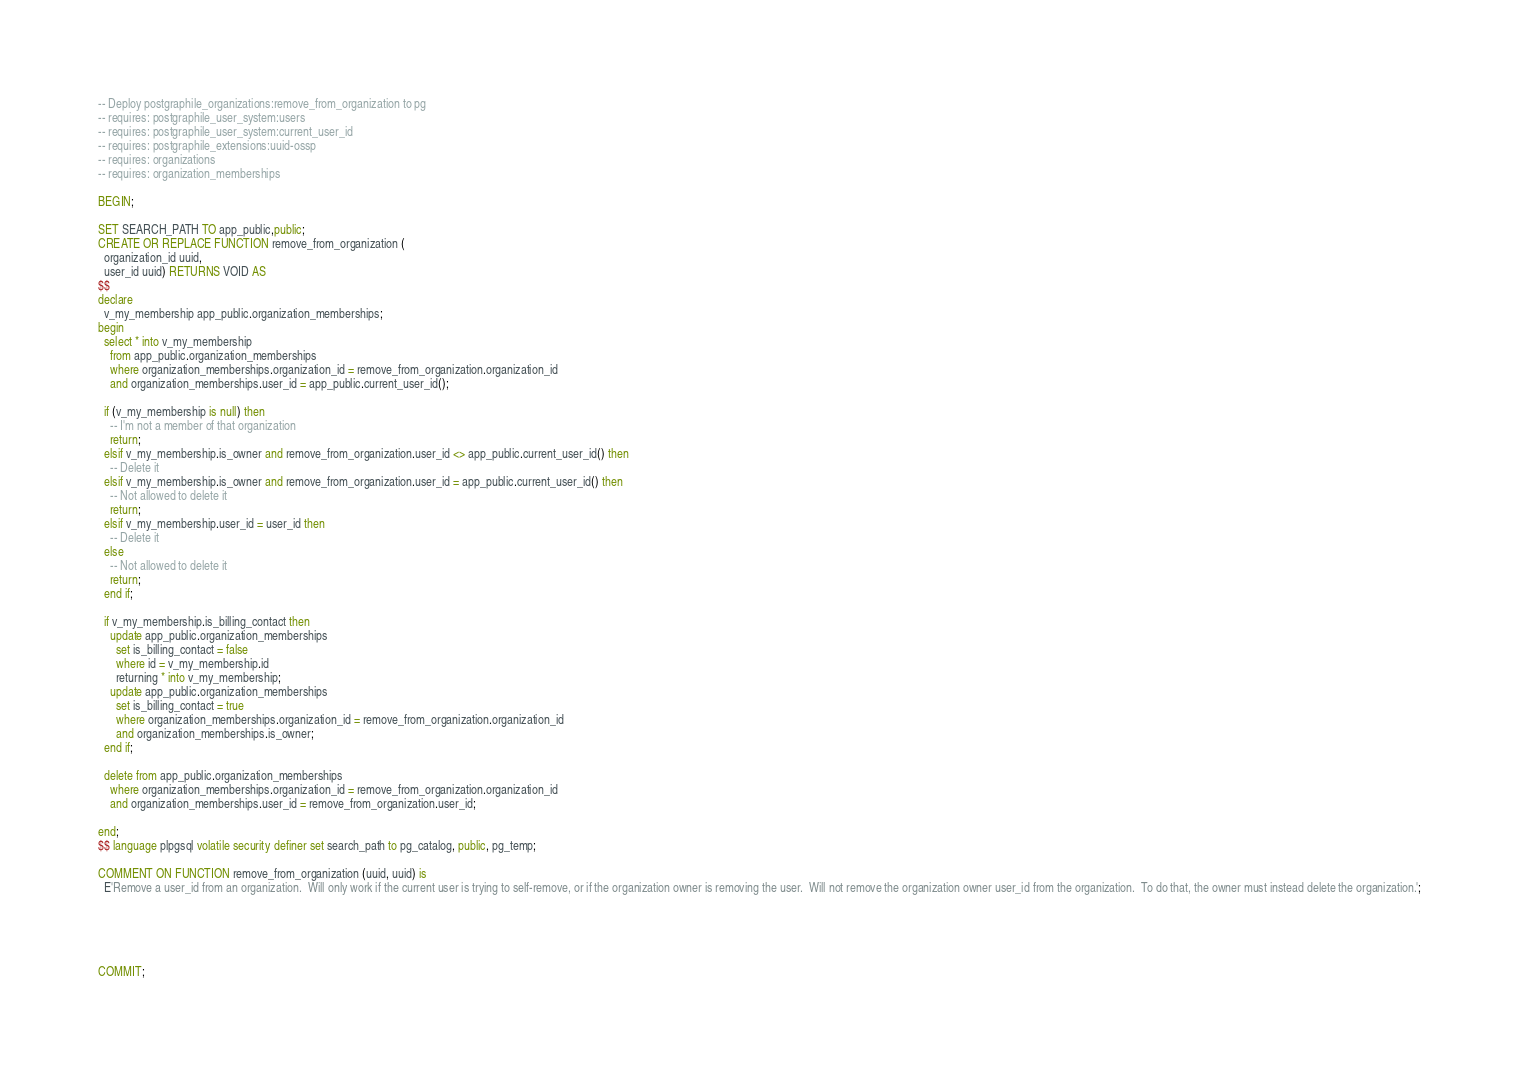Convert code to text. <code><loc_0><loc_0><loc_500><loc_500><_SQL_>-- Deploy postgraphile_organizations:remove_from_organization to pg
-- requires: postgraphile_user_system:users
-- requires: postgraphile_user_system:current_user_id
-- requires: postgraphile_extensions:uuid-ossp
-- requires: organizations
-- requires: organization_memberships

BEGIN;

SET SEARCH_PATH TO app_public,public;
CREATE OR REPLACE FUNCTION remove_from_organization (
  organization_id uuid,
  user_id uuid) RETURNS VOID AS
$$
declare
  v_my_membership app_public.organization_memberships;
begin
  select * into v_my_membership
    from app_public.organization_memberships
    where organization_memberships.organization_id = remove_from_organization.organization_id
    and organization_memberships.user_id = app_public.current_user_id();

  if (v_my_membership is null) then
    -- I'm not a member of that organization
    return;
  elsif v_my_membership.is_owner and remove_from_organization.user_id <> app_public.current_user_id() then
    -- Delete it
  elsif v_my_membership.is_owner and remove_from_organization.user_id = app_public.current_user_id() then
    -- Not allowed to delete it
    return;
  elsif v_my_membership.user_id = user_id then
    -- Delete it
  else
    -- Not allowed to delete it
    return;
  end if;

  if v_my_membership.is_billing_contact then
    update app_public.organization_memberships
      set is_billing_contact = false
      where id = v_my_membership.id
      returning * into v_my_membership;
    update app_public.organization_memberships
      set is_billing_contact = true
      where organization_memberships.organization_id = remove_from_organization.organization_id
      and organization_memberships.is_owner;
  end if;

  delete from app_public.organization_memberships
    where organization_memberships.organization_id = remove_from_organization.organization_id
    and organization_memberships.user_id = remove_from_organization.user_id;

end;
$$ language plpgsql volatile security definer set search_path to pg_catalog, public, pg_temp;

COMMENT ON FUNCTION remove_from_organization (uuid, uuid) is
  E'Remove a user_id from an organization.  Will only work if the current user is trying to self-remove, or if the organization owner is removing the user.  Will not remove the organization owner user_id from the organization.  To do that, the owner must instead delete the organization.';





COMMIT;
</code> 